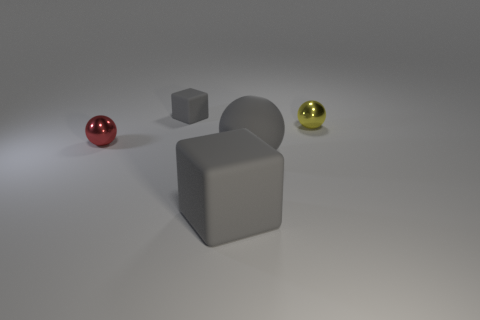Do the red shiny thing and the yellow metallic object have the same shape?
Your response must be concise. Yes. There is a yellow ball that is the same size as the red metal thing; what is its material?
Keep it short and to the point. Metal. What shape is the gray object that is the same size as the yellow metallic object?
Your response must be concise. Cube. What number of other things are there of the same color as the large sphere?
Offer a terse response. 2. Is the cube in front of the small gray block made of the same material as the red thing?
Keep it short and to the point. No. What is the shape of the small shiny object to the right of the red thing?
Ensure brevity in your answer.  Sphere. What number of metal things are the same size as the matte ball?
Keep it short and to the point. 0. What is the size of the gray matte ball?
Your answer should be very brief. Large. There is a small yellow sphere; what number of tiny balls are in front of it?
Offer a very short reply. 1. There is a small thing that is made of the same material as the gray ball; what shape is it?
Ensure brevity in your answer.  Cube. 